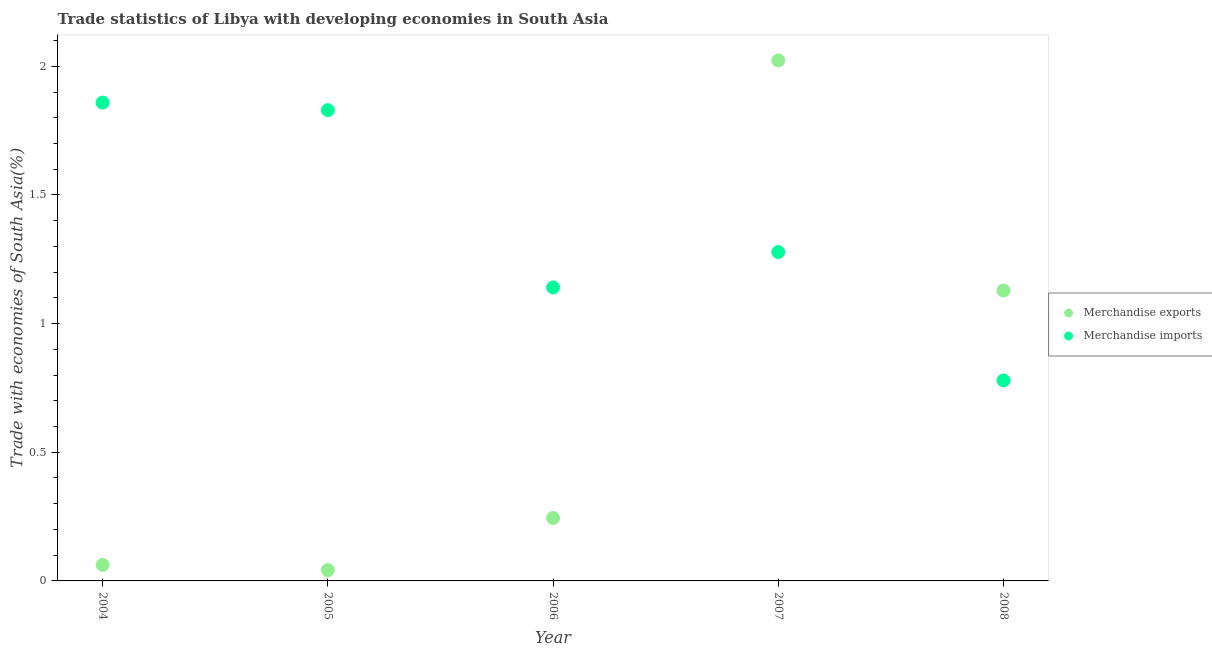Is the number of dotlines equal to the number of legend labels?
Offer a very short reply. Yes. What is the merchandise exports in 2005?
Your answer should be very brief. 0.04. Across all years, what is the maximum merchandise exports?
Offer a terse response. 2.02. Across all years, what is the minimum merchandise imports?
Ensure brevity in your answer.  0.78. In which year was the merchandise imports maximum?
Make the answer very short. 2004. What is the total merchandise exports in the graph?
Your answer should be very brief. 3.5. What is the difference between the merchandise exports in 2004 and that in 2007?
Provide a short and direct response. -1.96. What is the difference between the merchandise exports in 2006 and the merchandise imports in 2008?
Provide a succinct answer. -0.53. What is the average merchandise exports per year?
Your answer should be very brief. 0.7. In the year 2008, what is the difference between the merchandise exports and merchandise imports?
Offer a terse response. 0.35. In how many years, is the merchandise imports greater than 0.7 %?
Keep it short and to the point. 5. What is the ratio of the merchandise exports in 2007 to that in 2008?
Make the answer very short. 1.79. What is the difference between the highest and the second highest merchandise imports?
Keep it short and to the point. 0.03. What is the difference between the highest and the lowest merchandise imports?
Offer a terse response. 1.08. In how many years, is the merchandise imports greater than the average merchandise imports taken over all years?
Your answer should be compact. 2. Is the merchandise exports strictly less than the merchandise imports over the years?
Keep it short and to the point. No. How many dotlines are there?
Make the answer very short. 2. What is the difference between two consecutive major ticks on the Y-axis?
Provide a short and direct response. 0.5. Are the values on the major ticks of Y-axis written in scientific E-notation?
Make the answer very short. No. What is the title of the graph?
Your response must be concise. Trade statistics of Libya with developing economies in South Asia. What is the label or title of the X-axis?
Offer a terse response. Year. What is the label or title of the Y-axis?
Your answer should be very brief. Trade with economies of South Asia(%). What is the Trade with economies of South Asia(%) of Merchandise exports in 2004?
Keep it short and to the point. 0.06. What is the Trade with economies of South Asia(%) of Merchandise imports in 2004?
Offer a terse response. 1.86. What is the Trade with economies of South Asia(%) in Merchandise exports in 2005?
Your answer should be compact. 0.04. What is the Trade with economies of South Asia(%) of Merchandise imports in 2005?
Make the answer very short. 1.83. What is the Trade with economies of South Asia(%) in Merchandise exports in 2006?
Keep it short and to the point. 0.24. What is the Trade with economies of South Asia(%) of Merchandise imports in 2006?
Your answer should be compact. 1.14. What is the Trade with economies of South Asia(%) in Merchandise exports in 2007?
Ensure brevity in your answer.  2.02. What is the Trade with economies of South Asia(%) of Merchandise imports in 2007?
Your answer should be compact. 1.28. What is the Trade with economies of South Asia(%) in Merchandise exports in 2008?
Ensure brevity in your answer.  1.13. What is the Trade with economies of South Asia(%) of Merchandise imports in 2008?
Your answer should be very brief. 0.78. Across all years, what is the maximum Trade with economies of South Asia(%) in Merchandise exports?
Your answer should be very brief. 2.02. Across all years, what is the maximum Trade with economies of South Asia(%) of Merchandise imports?
Provide a short and direct response. 1.86. Across all years, what is the minimum Trade with economies of South Asia(%) of Merchandise exports?
Give a very brief answer. 0.04. Across all years, what is the minimum Trade with economies of South Asia(%) of Merchandise imports?
Your response must be concise. 0.78. What is the total Trade with economies of South Asia(%) in Merchandise exports in the graph?
Provide a short and direct response. 3.5. What is the total Trade with economies of South Asia(%) of Merchandise imports in the graph?
Give a very brief answer. 6.89. What is the difference between the Trade with economies of South Asia(%) in Merchandise exports in 2004 and that in 2005?
Offer a very short reply. 0.02. What is the difference between the Trade with economies of South Asia(%) in Merchandise imports in 2004 and that in 2005?
Offer a very short reply. 0.03. What is the difference between the Trade with economies of South Asia(%) of Merchandise exports in 2004 and that in 2006?
Offer a terse response. -0.18. What is the difference between the Trade with economies of South Asia(%) of Merchandise imports in 2004 and that in 2006?
Keep it short and to the point. 0.72. What is the difference between the Trade with economies of South Asia(%) of Merchandise exports in 2004 and that in 2007?
Provide a succinct answer. -1.96. What is the difference between the Trade with economies of South Asia(%) of Merchandise imports in 2004 and that in 2007?
Your response must be concise. 0.58. What is the difference between the Trade with economies of South Asia(%) of Merchandise exports in 2004 and that in 2008?
Your answer should be very brief. -1.07. What is the difference between the Trade with economies of South Asia(%) in Merchandise imports in 2004 and that in 2008?
Keep it short and to the point. 1.08. What is the difference between the Trade with economies of South Asia(%) in Merchandise exports in 2005 and that in 2006?
Your answer should be very brief. -0.2. What is the difference between the Trade with economies of South Asia(%) of Merchandise imports in 2005 and that in 2006?
Make the answer very short. 0.69. What is the difference between the Trade with economies of South Asia(%) of Merchandise exports in 2005 and that in 2007?
Provide a succinct answer. -1.98. What is the difference between the Trade with economies of South Asia(%) in Merchandise imports in 2005 and that in 2007?
Offer a terse response. 0.55. What is the difference between the Trade with economies of South Asia(%) of Merchandise exports in 2005 and that in 2008?
Keep it short and to the point. -1.09. What is the difference between the Trade with economies of South Asia(%) of Merchandise imports in 2005 and that in 2008?
Your answer should be very brief. 1.05. What is the difference between the Trade with economies of South Asia(%) of Merchandise exports in 2006 and that in 2007?
Make the answer very short. -1.78. What is the difference between the Trade with economies of South Asia(%) of Merchandise imports in 2006 and that in 2007?
Provide a short and direct response. -0.14. What is the difference between the Trade with economies of South Asia(%) in Merchandise exports in 2006 and that in 2008?
Provide a succinct answer. -0.88. What is the difference between the Trade with economies of South Asia(%) of Merchandise imports in 2006 and that in 2008?
Keep it short and to the point. 0.36. What is the difference between the Trade with economies of South Asia(%) in Merchandise exports in 2007 and that in 2008?
Give a very brief answer. 0.89. What is the difference between the Trade with economies of South Asia(%) of Merchandise imports in 2007 and that in 2008?
Provide a succinct answer. 0.5. What is the difference between the Trade with economies of South Asia(%) in Merchandise exports in 2004 and the Trade with economies of South Asia(%) in Merchandise imports in 2005?
Offer a terse response. -1.77. What is the difference between the Trade with economies of South Asia(%) of Merchandise exports in 2004 and the Trade with economies of South Asia(%) of Merchandise imports in 2006?
Your response must be concise. -1.08. What is the difference between the Trade with economies of South Asia(%) of Merchandise exports in 2004 and the Trade with economies of South Asia(%) of Merchandise imports in 2007?
Your response must be concise. -1.22. What is the difference between the Trade with economies of South Asia(%) of Merchandise exports in 2004 and the Trade with economies of South Asia(%) of Merchandise imports in 2008?
Your answer should be compact. -0.72. What is the difference between the Trade with economies of South Asia(%) in Merchandise exports in 2005 and the Trade with economies of South Asia(%) in Merchandise imports in 2006?
Ensure brevity in your answer.  -1.1. What is the difference between the Trade with economies of South Asia(%) in Merchandise exports in 2005 and the Trade with economies of South Asia(%) in Merchandise imports in 2007?
Keep it short and to the point. -1.24. What is the difference between the Trade with economies of South Asia(%) in Merchandise exports in 2005 and the Trade with economies of South Asia(%) in Merchandise imports in 2008?
Provide a short and direct response. -0.74. What is the difference between the Trade with economies of South Asia(%) of Merchandise exports in 2006 and the Trade with economies of South Asia(%) of Merchandise imports in 2007?
Keep it short and to the point. -1.03. What is the difference between the Trade with economies of South Asia(%) in Merchandise exports in 2006 and the Trade with economies of South Asia(%) in Merchandise imports in 2008?
Your answer should be very brief. -0.53. What is the difference between the Trade with economies of South Asia(%) in Merchandise exports in 2007 and the Trade with economies of South Asia(%) in Merchandise imports in 2008?
Offer a very short reply. 1.24. What is the average Trade with economies of South Asia(%) in Merchandise exports per year?
Make the answer very short. 0.7. What is the average Trade with economies of South Asia(%) of Merchandise imports per year?
Make the answer very short. 1.38. In the year 2004, what is the difference between the Trade with economies of South Asia(%) in Merchandise exports and Trade with economies of South Asia(%) in Merchandise imports?
Offer a terse response. -1.8. In the year 2005, what is the difference between the Trade with economies of South Asia(%) of Merchandise exports and Trade with economies of South Asia(%) of Merchandise imports?
Provide a short and direct response. -1.79. In the year 2006, what is the difference between the Trade with economies of South Asia(%) in Merchandise exports and Trade with economies of South Asia(%) in Merchandise imports?
Your answer should be very brief. -0.9. In the year 2007, what is the difference between the Trade with economies of South Asia(%) of Merchandise exports and Trade with economies of South Asia(%) of Merchandise imports?
Your response must be concise. 0.74. In the year 2008, what is the difference between the Trade with economies of South Asia(%) in Merchandise exports and Trade with economies of South Asia(%) in Merchandise imports?
Provide a short and direct response. 0.35. What is the ratio of the Trade with economies of South Asia(%) of Merchandise exports in 2004 to that in 2005?
Your answer should be compact. 1.48. What is the ratio of the Trade with economies of South Asia(%) in Merchandise imports in 2004 to that in 2005?
Ensure brevity in your answer.  1.02. What is the ratio of the Trade with economies of South Asia(%) of Merchandise exports in 2004 to that in 2006?
Ensure brevity in your answer.  0.25. What is the ratio of the Trade with economies of South Asia(%) in Merchandise imports in 2004 to that in 2006?
Give a very brief answer. 1.63. What is the ratio of the Trade with economies of South Asia(%) in Merchandise exports in 2004 to that in 2007?
Give a very brief answer. 0.03. What is the ratio of the Trade with economies of South Asia(%) in Merchandise imports in 2004 to that in 2007?
Give a very brief answer. 1.45. What is the ratio of the Trade with economies of South Asia(%) of Merchandise exports in 2004 to that in 2008?
Offer a terse response. 0.06. What is the ratio of the Trade with economies of South Asia(%) of Merchandise imports in 2004 to that in 2008?
Your response must be concise. 2.39. What is the ratio of the Trade with economies of South Asia(%) of Merchandise exports in 2005 to that in 2006?
Make the answer very short. 0.17. What is the ratio of the Trade with economies of South Asia(%) of Merchandise imports in 2005 to that in 2006?
Provide a succinct answer. 1.6. What is the ratio of the Trade with economies of South Asia(%) in Merchandise exports in 2005 to that in 2007?
Your response must be concise. 0.02. What is the ratio of the Trade with economies of South Asia(%) in Merchandise imports in 2005 to that in 2007?
Give a very brief answer. 1.43. What is the ratio of the Trade with economies of South Asia(%) of Merchandise exports in 2005 to that in 2008?
Your answer should be compact. 0.04. What is the ratio of the Trade with economies of South Asia(%) in Merchandise imports in 2005 to that in 2008?
Offer a very short reply. 2.35. What is the ratio of the Trade with economies of South Asia(%) of Merchandise exports in 2006 to that in 2007?
Give a very brief answer. 0.12. What is the ratio of the Trade with economies of South Asia(%) of Merchandise imports in 2006 to that in 2007?
Offer a terse response. 0.89. What is the ratio of the Trade with economies of South Asia(%) of Merchandise exports in 2006 to that in 2008?
Keep it short and to the point. 0.22. What is the ratio of the Trade with economies of South Asia(%) in Merchandise imports in 2006 to that in 2008?
Ensure brevity in your answer.  1.46. What is the ratio of the Trade with economies of South Asia(%) of Merchandise exports in 2007 to that in 2008?
Make the answer very short. 1.79. What is the ratio of the Trade with economies of South Asia(%) of Merchandise imports in 2007 to that in 2008?
Provide a succinct answer. 1.64. What is the difference between the highest and the second highest Trade with economies of South Asia(%) of Merchandise exports?
Keep it short and to the point. 0.89. What is the difference between the highest and the second highest Trade with economies of South Asia(%) of Merchandise imports?
Offer a terse response. 0.03. What is the difference between the highest and the lowest Trade with economies of South Asia(%) of Merchandise exports?
Make the answer very short. 1.98. What is the difference between the highest and the lowest Trade with economies of South Asia(%) of Merchandise imports?
Make the answer very short. 1.08. 